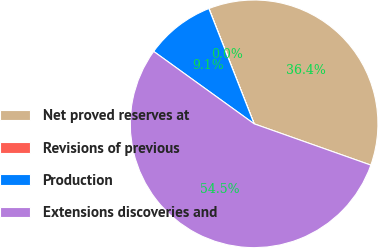Convert chart to OTSL. <chart><loc_0><loc_0><loc_500><loc_500><pie_chart><fcel>Net proved reserves at<fcel>Revisions of previous<fcel>Production<fcel>Extensions discoveries and<nl><fcel>36.36%<fcel>0.01%<fcel>9.1%<fcel>54.53%<nl></chart> 